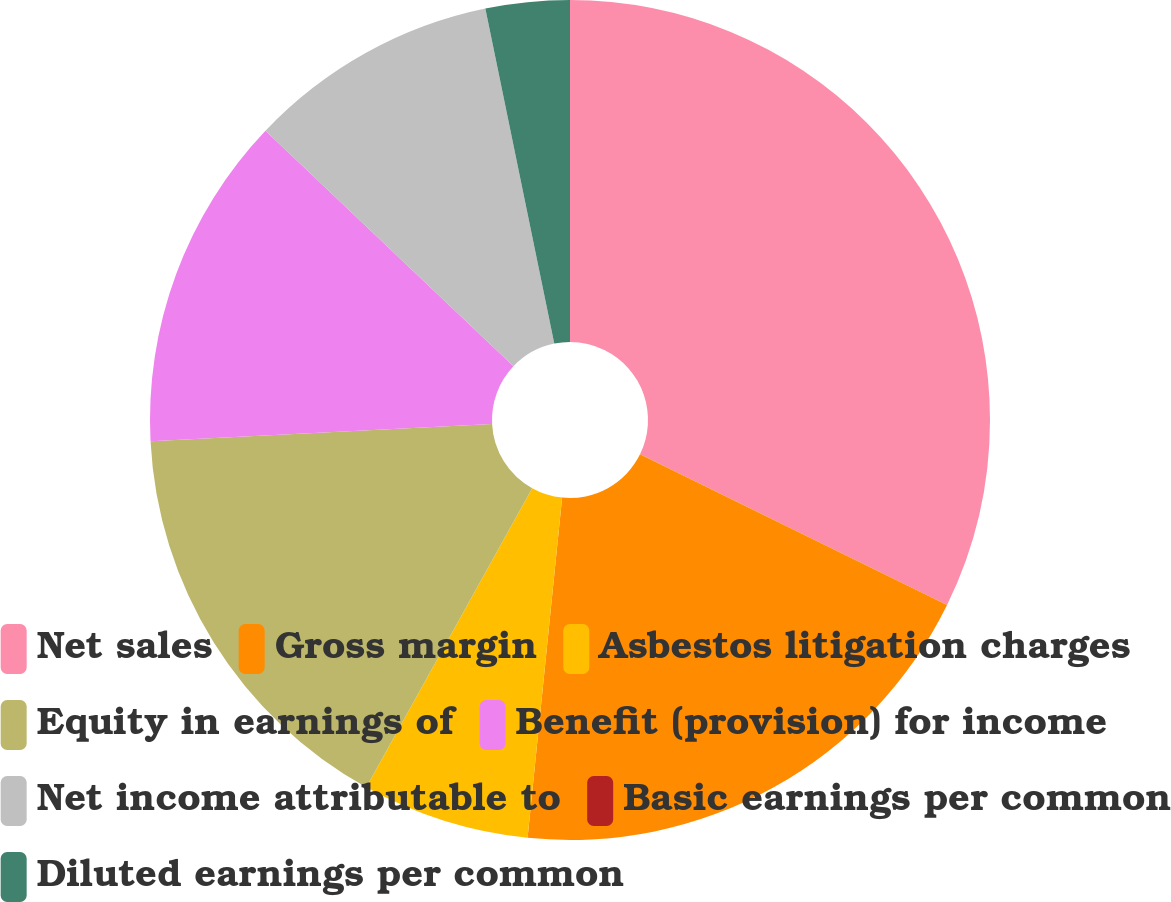Convert chart. <chart><loc_0><loc_0><loc_500><loc_500><pie_chart><fcel>Net sales<fcel>Gross margin<fcel>Asbestos litigation charges<fcel>Equity in earnings of<fcel>Benefit (provision) for income<fcel>Net income attributable to<fcel>Basic earnings per common<fcel>Diluted earnings per common<nl><fcel>32.26%<fcel>19.35%<fcel>6.45%<fcel>16.13%<fcel>12.9%<fcel>9.68%<fcel>0.0%<fcel>3.23%<nl></chart> 